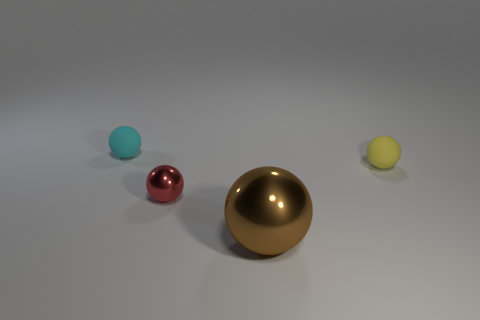What is the atmosphere or mood communicated by this scene, and what elements contribute to it? The scene conveys a calm and minimalist atmosphere. Elements contributing to this mood include the soft lighting, neutral background, and the simple arrangement of the spherical objects with varying finishes and colors. 